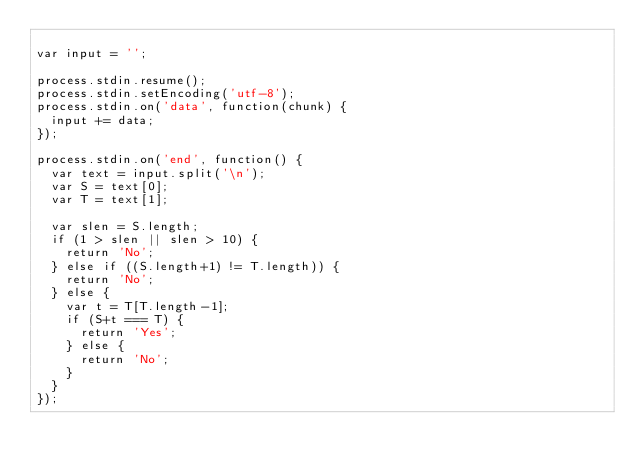<code> <loc_0><loc_0><loc_500><loc_500><_JavaScript_>
var input = '';

process.stdin.resume();
process.stdin.setEncoding('utf-8');
process.stdin.on('data', function(chunk) {
  input += data;
});

process.stdin.on('end', function() {
  var text = input.split('\n');
  var S = text[0];
  var T = text[1];
  
  var slen = S.length;
  if (1 > slen || slen > 10) {
    return 'No';
  } else if ((S.length+1) != T.length)) {
    return 'No';
  } else {
  	var t = T[T.length-1];
    if (S+t === T) {
      return 'Yes';
    } else {
      return 'No';
    }
  }
});</code> 